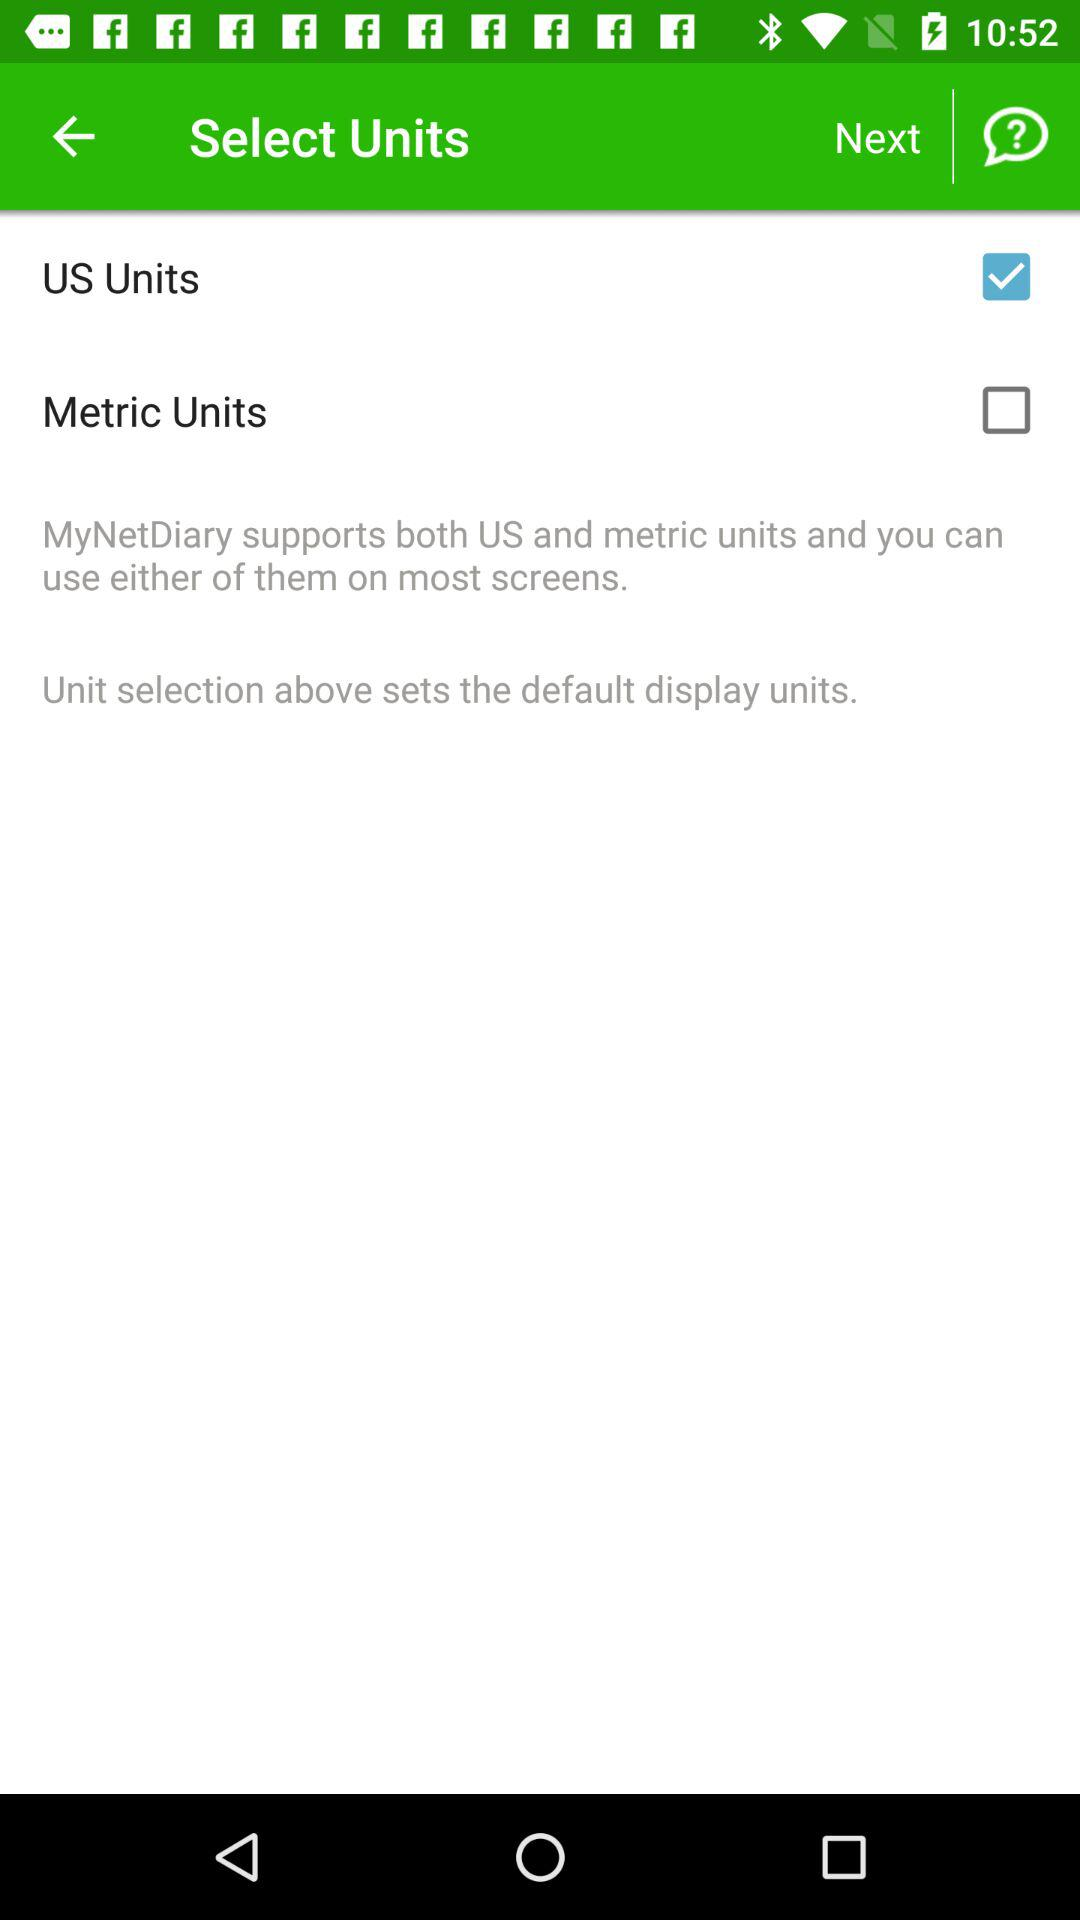How many units are available for selection?
Answer the question using a single word or phrase. 2 